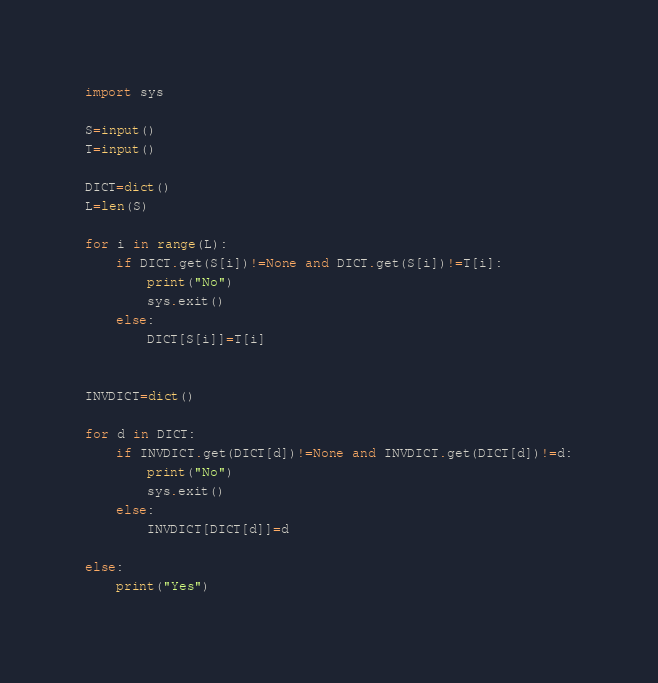Convert code to text. <code><loc_0><loc_0><loc_500><loc_500><_Python_>import sys

S=input()
T=input()

DICT=dict()
L=len(S)

for i in range(L):
    if DICT.get(S[i])!=None and DICT.get(S[i])!=T[i]:
        print("No")
        sys.exit()
    else:
        DICT[S[i]]=T[i]


INVDICT=dict()

for d in DICT:
    if INVDICT.get(DICT[d])!=None and INVDICT.get(DICT[d])!=d:
        print("No")
        sys.exit()
    else:
        INVDICT[DICT[d]]=d

else:
    print("Yes")</code> 